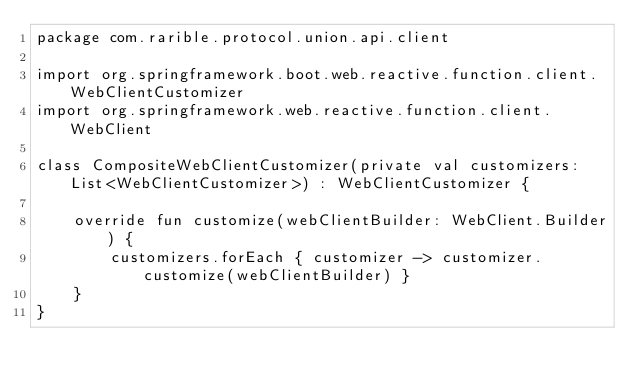Convert code to text. <code><loc_0><loc_0><loc_500><loc_500><_Kotlin_>package com.rarible.protocol.union.api.client

import org.springframework.boot.web.reactive.function.client.WebClientCustomizer
import org.springframework.web.reactive.function.client.WebClient

class CompositeWebClientCustomizer(private val customizers: List<WebClientCustomizer>) : WebClientCustomizer {

    override fun customize(webClientBuilder: WebClient.Builder) {
        customizers.forEach { customizer -> customizer.customize(webClientBuilder) }
    }
}</code> 